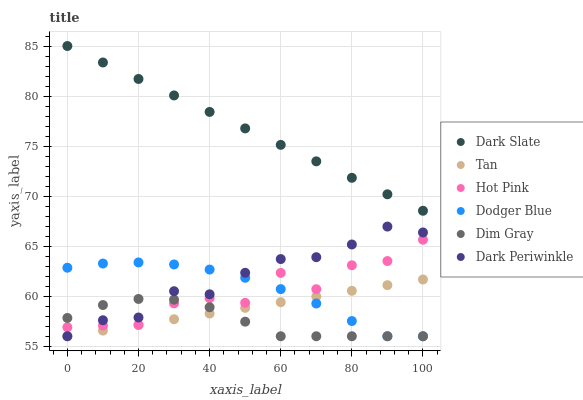Does Dim Gray have the minimum area under the curve?
Answer yes or no. Yes. Does Dark Slate have the maximum area under the curve?
Answer yes or no. Yes. Does Hot Pink have the minimum area under the curve?
Answer yes or no. No. Does Hot Pink have the maximum area under the curve?
Answer yes or no. No. Is Dark Slate the smoothest?
Answer yes or no. Yes. Is Hot Pink the roughest?
Answer yes or no. Yes. Is Hot Pink the smoothest?
Answer yes or no. No. Is Dark Slate the roughest?
Answer yes or no. No. Does Dim Gray have the lowest value?
Answer yes or no. Yes. Does Hot Pink have the lowest value?
Answer yes or no. No. Does Dark Slate have the highest value?
Answer yes or no. Yes. Does Hot Pink have the highest value?
Answer yes or no. No. Is Dark Periwinkle less than Dark Slate?
Answer yes or no. Yes. Is Dark Slate greater than Hot Pink?
Answer yes or no. Yes. Does Dodger Blue intersect Dark Periwinkle?
Answer yes or no. Yes. Is Dodger Blue less than Dark Periwinkle?
Answer yes or no. No. Is Dodger Blue greater than Dark Periwinkle?
Answer yes or no. No. Does Dark Periwinkle intersect Dark Slate?
Answer yes or no. No. 